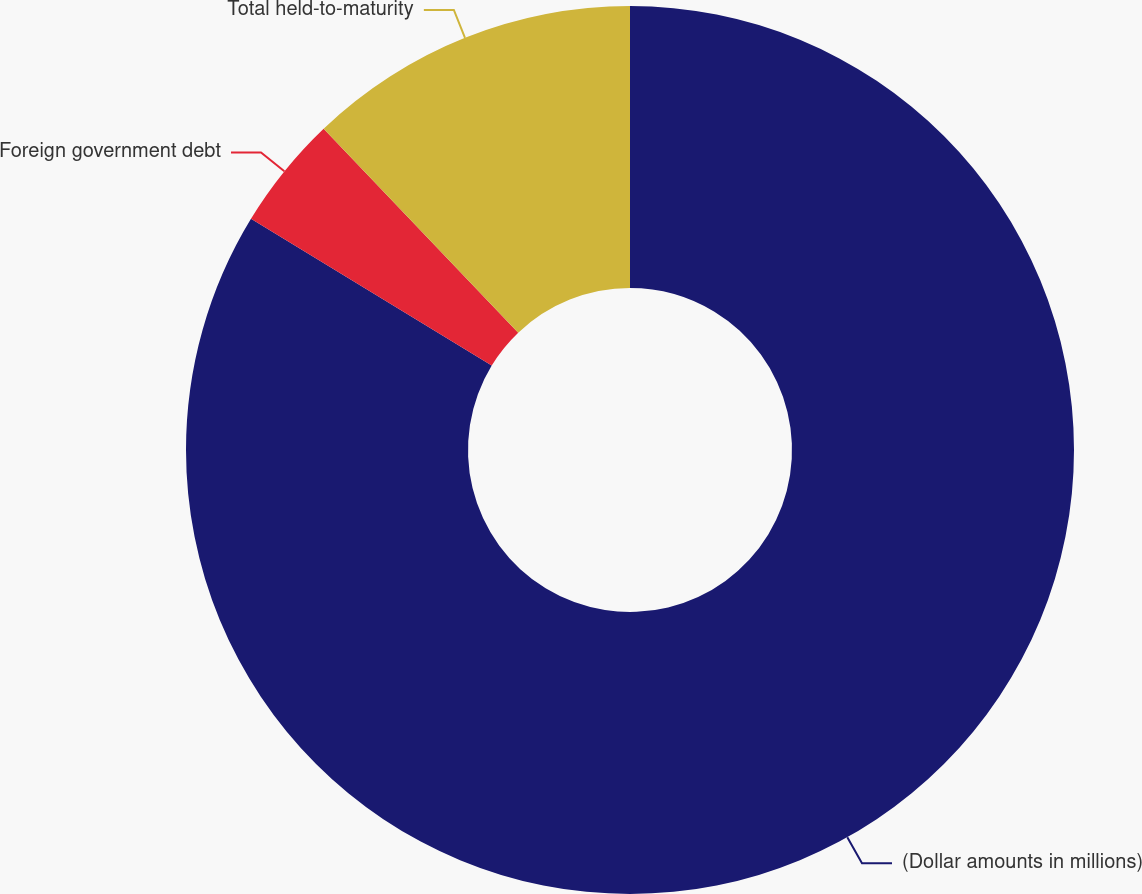Convert chart to OTSL. <chart><loc_0><loc_0><loc_500><loc_500><pie_chart><fcel>(Dollar amounts in millions)<fcel>Foreign government debt<fcel>Total held-to-maturity<nl><fcel>83.72%<fcel>4.16%<fcel>12.12%<nl></chart> 